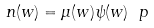<formula> <loc_0><loc_0><loc_500><loc_500>n ( w ) = \mu ( w ) \psi ( w ) \ p</formula> 